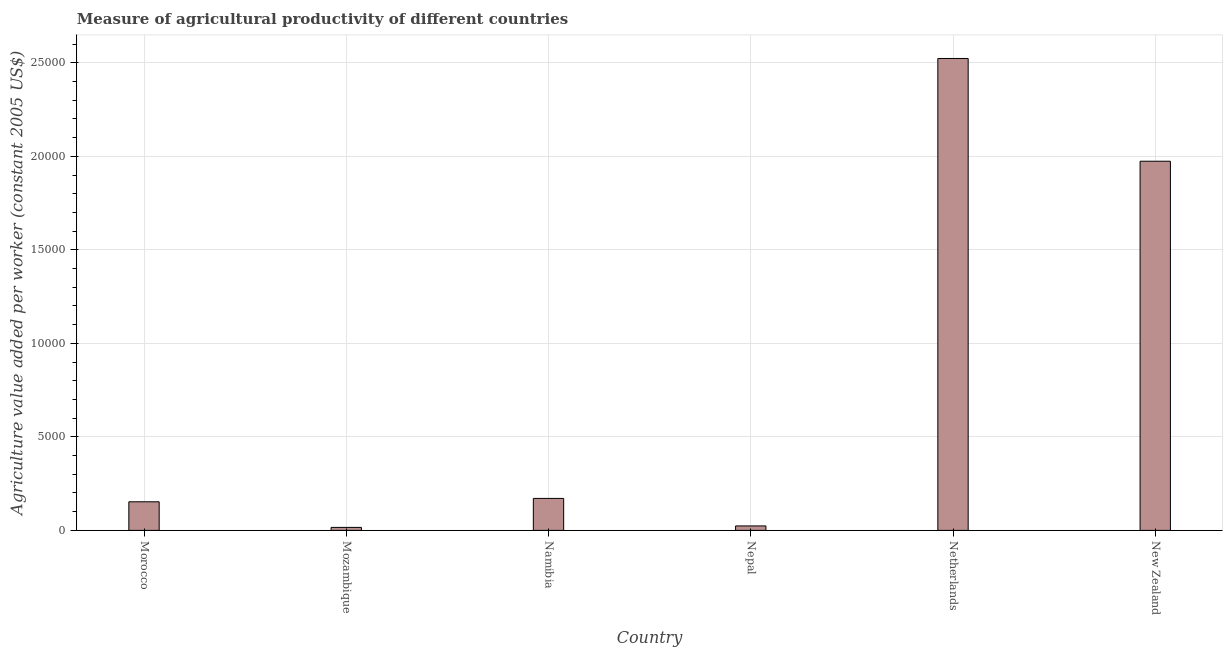Does the graph contain any zero values?
Your answer should be compact. No. What is the title of the graph?
Keep it short and to the point. Measure of agricultural productivity of different countries. What is the label or title of the X-axis?
Provide a succinct answer. Country. What is the label or title of the Y-axis?
Give a very brief answer. Agriculture value added per worker (constant 2005 US$). What is the agriculture value added per worker in Netherlands?
Offer a very short reply. 2.52e+04. Across all countries, what is the maximum agriculture value added per worker?
Your answer should be compact. 2.52e+04. Across all countries, what is the minimum agriculture value added per worker?
Provide a succinct answer. 159.84. In which country was the agriculture value added per worker maximum?
Your response must be concise. Netherlands. In which country was the agriculture value added per worker minimum?
Keep it short and to the point. Mozambique. What is the sum of the agriculture value added per worker?
Your answer should be very brief. 4.86e+04. What is the difference between the agriculture value added per worker in Morocco and New Zealand?
Provide a succinct answer. -1.82e+04. What is the average agriculture value added per worker per country?
Your response must be concise. 8102.21. What is the median agriculture value added per worker?
Your response must be concise. 1619.48. In how many countries, is the agriculture value added per worker greater than 9000 US$?
Your answer should be compact. 2. What is the ratio of the agriculture value added per worker in Nepal to that in New Zealand?
Ensure brevity in your answer.  0.01. Is the agriculture value added per worker in Morocco less than that in Mozambique?
Your response must be concise. No. Is the difference between the agriculture value added per worker in Morocco and Namibia greater than the difference between any two countries?
Your response must be concise. No. What is the difference between the highest and the second highest agriculture value added per worker?
Your answer should be compact. 5494.72. What is the difference between the highest and the lowest agriculture value added per worker?
Offer a very short reply. 2.51e+04. In how many countries, is the agriculture value added per worker greater than the average agriculture value added per worker taken over all countries?
Your answer should be compact. 2. Are all the bars in the graph horizontal?
Give a very brief answer. No. How many countries are there in the graph?
Make the answer very short. 6. What is the difference between two consecutive major ticks on the Y-axis?
Your answer should be very brief. 5000. What is the Agriculture value added per worker (constant 2005 US$) of Morocco?
Offer a very short reply. 1529.19. What is the Agriculture value added per worker (constant 2005 US$) in Mozambique?
Your answer should be compact. 159.84. What is the Agriculture value added per worker (constant 2005 US$) in Namibia?
Keep it short and to the point. 1709.78. What is the Agriculture value added per worker (constant 2005 US$) of Nepal?
Give a very brief answer. 238.63. What is the Agriculture value added per worker (constant 2005 US$) of Netherlands?
Your response must be concise. 2.52e+04. What is the Agriculture value added per worker (constant 2005 US$) in New Zealand?
Your response must be concise. 1.97e+04. What is the difference between the Agriculture value added per worker (constant 2005 US$) in Morocco and Mozambique?
Keep it short and to the point. 1369.35. What is the difference between the Agriculture value added per worker (constant 2005 US$) in Morocco and Namibia?
Give a very brief answer. -180.59. What is the difference between the Agriculture value added per worker (constant 2005 US$) in Morocco and Nepal?
Make the answer very short. 1290.56. What is the difference between the Agriculture value added per worker (constant 2005 US$) in Morocco and Netherlands?
Your answer should be compact. -2.37e+04. What is the difference between the Agriculture value added per worker (constant 2005 US$) in Morocco and New Zealand?
Your response must be concise. -1.82e+04. What is the difference between the Agriculture value added per worker (constant 2005 US$) in Mozambique and Namibia?
Offer a very short reply. -1549.94. What is the difference between the Agriculture value added per worker (constant 2005 US$) in Mozambique and Nepal?
Your answer should be compact. -78.79. What is the difference between the Agriculture value added per worker (constant 2005 US$) in Mozambique and Netherlands?
Offer a terse response. -2.51e+04. What is the difference between the Agriculture value added per worker (constant 2005 US$) in Mozambique and New Zealand?
Ensure brevity in your answer.  -1.96e+04. What is the difference between the Agriculture value added per worker (constant 2005 US$) in Namibia and Nepal?
Give a very brief answer. 1471.15. What is the difference between the Agriculture value added per worker (constant 2005 US$) in Namibia and Netherlands?
Provide a succinct answer. -2.35e+04. What is the difference between the Agriculture value added per worker (constant 2005 US$) in Namibia and New Zealand?
Offer a terse response. -1.80e+04. What is the difference between the Agriculture value added per worker (constant 2005 US$) in Nepal and Netherlands?
Keep it short and to the point. -2.50e+04. What is the difference between the Agriculture value added per worker (constant 2005 US$) in Nepal and New Zealand?
Keep it short and to the point. -1.95e+04. What is the difference between the Agriculture value added per worker (constant 2005 US$) in Netherlands and New Zealand?
Provide a succinct answer. 5494.72. What is the ratio of the Agriculture value added per worker (constant 2005 US$) in Morocco to that in Mozambique?
Make the answer very short. 9.57. What is the ratio of the Agriculture value added per worker (constant 2005 US$) in Morocco to that in Namibia?
Make the answer very short. 0.89. What is the ratio of the Agriculture value added per worker (constant 2005 US$) in Morocco to that in Nepal?
Offer a very short reply. 6.41. What is the ratio of the Agriculture value added per worker (constant 2005 US$) in Morocco to that in Netherlands?
Your answer should be compact. 0.06. What is the ratio of the Agriculture value added per worker (constant 2005 US$) in Morocco to that in New Zealand?
Give a very brief answer. 0.08. What is the ratio of the Agriculture value added per worker (constant 2005 US$) in Mozambique to that in Namibia?
Your answer should be compact. 0.09. What is the ratio of the Agriculture value added per worker (constant 2005 US$) in Mozambique to that in Nepal?
Give a very brief answer. 0.67. What is the ratio of the Agriculture value added per worker (constant 2005 US$) in Mozambique to that in Netherlands?
Give a very brief answer. 0.01. What is the ratio of the Agriculture value added per worker (constant 2005 US$) in Mozambique to that in New Zealand?
Your answer should be very brief. 0.01. What is the ratio of the Agriculture value added per worker (constant 2005 US$) in Namibia to that in Nepal?
Ensure brevity in your answer.  7.17. What is the ratio of the Agriculture value added per worker (constant 2005 US$) in Namibia to that in Netherlands?
Make the answer very short. 0.07. What is the ratio of the Agriculture value added per worker (constant 2005 US$) in Namibia to that in New Zealand?
Your answer should be very brief. 0.09. What is the ratio of the Agriculture value added per worker (constant 2005 US$) in Nepal to that in Netherlands?
Offer a terse response. 0.01. What is the ratio of the Agriculture value added per worker (constant 2005 US$) in Nepal to that in New Zealand?
Offer a terse response. 0.01. What is the ratio of the Agriculture value added per worker (constant 2005 US$) in Netherlands to that in New Zealand?
Offer a terse response. 1.28. 